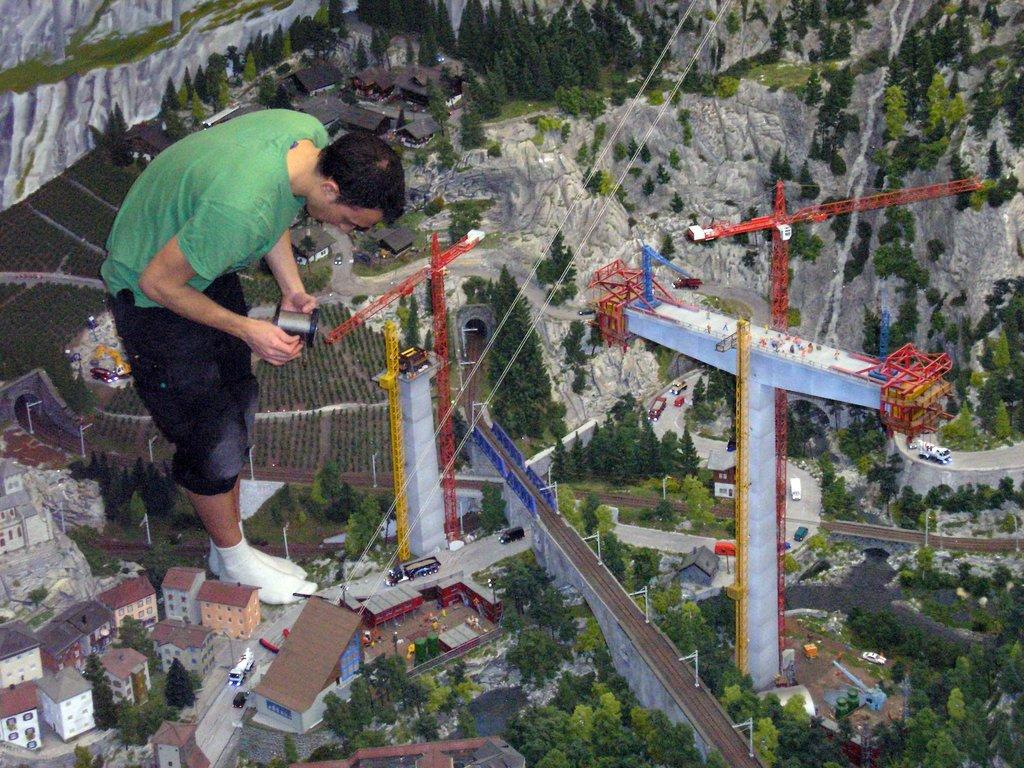What is the person in the image holding? The person is holding an object in the image. What type of toys can be seen in the image? There are toys that look like houses in the image. What natural elements are present in the image? There are trees and mountains in the image. What architectural features can be seen in the image? There are pillars and cranes in the image. What man-made objects are visible in the image? There are vehicles in the image. What type of income can be seen in the image? There is no reference to income in the image; it features a person holding an object, toys, trees, pillars, cranes, mountains, and vehicles. What type of pleasure can be seen in the image? There is no reference to pleasure in the image; it features a person holding an object, toys, trees, pillars, cranes, mountains, and vehicles. 